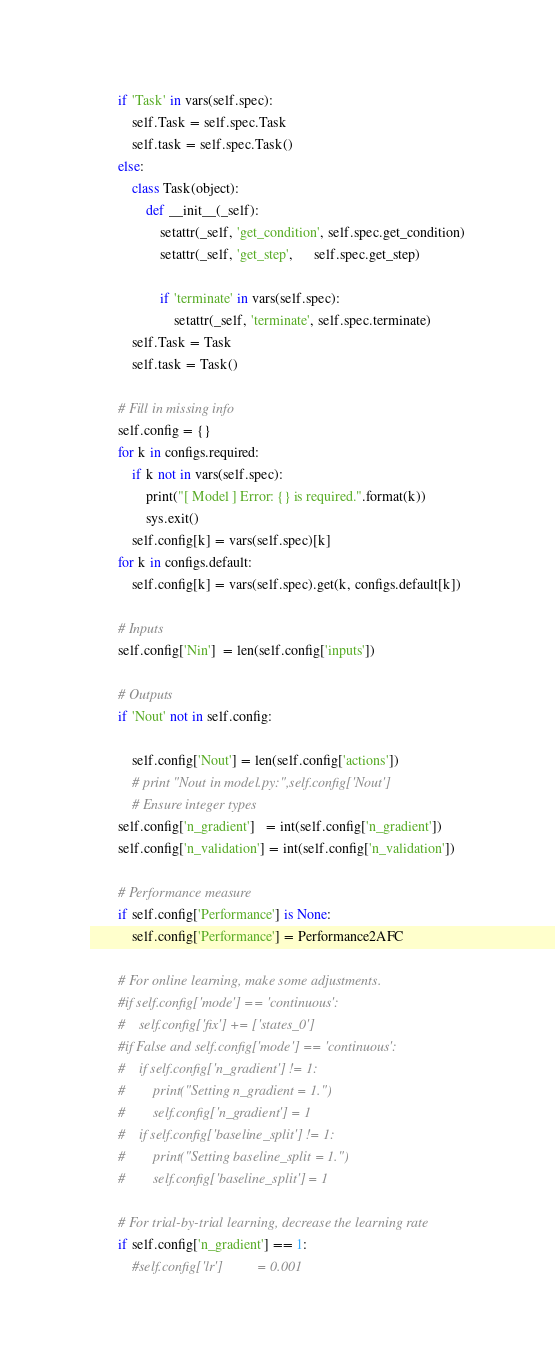<code> <loc_0><loc_0><loc_500><loc_500><_Python_>        if 'Task' in vars(self.spec):
            self.Task = self.spec.Task
            self.task = self.spec.Task()
        else:
            class Task(object):
                def __init__(_self):
                    setattr(_self, 'get_condition', self.spec.get_condition)
                    setattr(_self, 'get_step',      self.spec.get_step)

                    if 'terminate' in vars(self.spec):
                        setattr(_self, 'terminate', self.spec.terminate)
            self.Task = Task
            self.task = Task()

        # Fill in missing info
        self.config = {}
        for k in configs.required:
            if k not in vars(self.spec):
                print("[ Model ] Error: {} is required.".format(k))
                sys.exit()
            self.config[k] = vars(self.spec)[k]
        for k in configs.default:
            self.config[k] = vars(self.spec).get(k, configs.default[k])

        # Inputs
        self.config['Nin']  = len(self.config['inputs'])

        # Outputs
        if 'Nout' not in self.config:

            self.config['Nout'] = len(self.config['actions'])
            # print "Nout in model.py:",self.config['Nout']
            # Ensure integer types
        self.config['n_gradient']   = int(self.config['n_gradient'])
        self.config['n_validation'] = int(self.config['n_validation'])

        # Performance measure
        if self.config['Performance'] is None:
            self.config['Performance'] = Performance2AFC

        # For online learning, make some adjustments.
        #if self.config['mode'] == 'continuous':
        #    self.config['fix'] += ['states_0']
        #if False and self.config['mode'] == 'continuous':
        #    if self.config['n_gradient'] != 1:
        #        print("Setting n_gradient = 1.")
        #        self.config['n_gradient'] = 1
        #    if self.config['baseline_split'] != 1:
        #        print("Setting baseline_split = 1.")
        #        self.config['baseline_split'] = 1

        # For trial-by-trial learning, decrease the learning rate
        if self.config['n_gradient'] == 1:
            #self.config['lr']          = 0.001</code> 